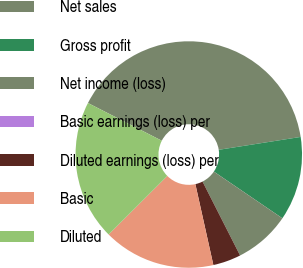Convert chart. <chart><loc_0><loc_0><loc_500><loc_500><pie_chart><fcel>Net sales<fcel>Gross profit<fcel>Net income (loss)<fcel>Basic earnings (loss) per<fcel>Diluted earnings (loss) per<fcel>Basic<fcel>Diluted<nl><fcel>40.0%<fcel>12.0%<fcel>8.0%<fcel>0.0%<fcel>4.0%<fcel>16.0%<fcel>20.0%<nl></chart> 